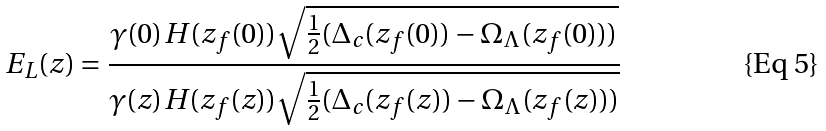<formula> <loc_0><loc_0><loc_500><loc_500>E _ { L } ( z ) = \frac { \gamma ( 0 ) H ( z _ { f } ( 0 ) ) \sqrt { \frac { 1 } { 2 } ( \Delta _ { c } ( z _ { f } ( 0 ) ) - \Omega _ { \Lambda } ( z _ { f } ( 0 ) ) ) } } { \gamma ( z ) H ( z _ { f } ( z ) ) \sqrt { \frac { 1 } { 2 } ( \Delta _ { c } ( z _ { f } ( z ) ) - \Omega _ { \Lambda } ( z _ { f } ( z ) ) ) } }</formula> 